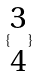Convert formula to latex. <formula><loc_0><loc_0><loc_500><loc_500>\{ \begin{matrix} 3 \\ 4 \end{matrix} \}</formula> 